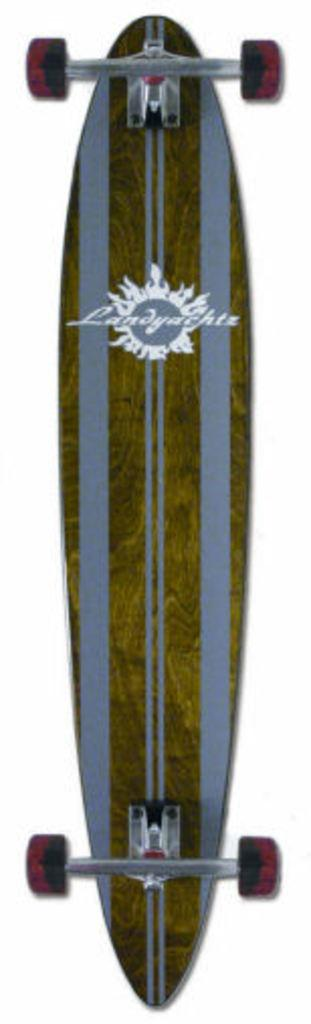What object is the main focus of the image? There is a skateboard in the image. Are there any words or designs on the skateboard? Yes, there is writing on the skateboard. What can be seen behind the skateboard in the image? There is a white background behind the skateboard. How many apples are on the skateboard in the image? There are no apples present in the image; it only features a skateboard with writing on it. 